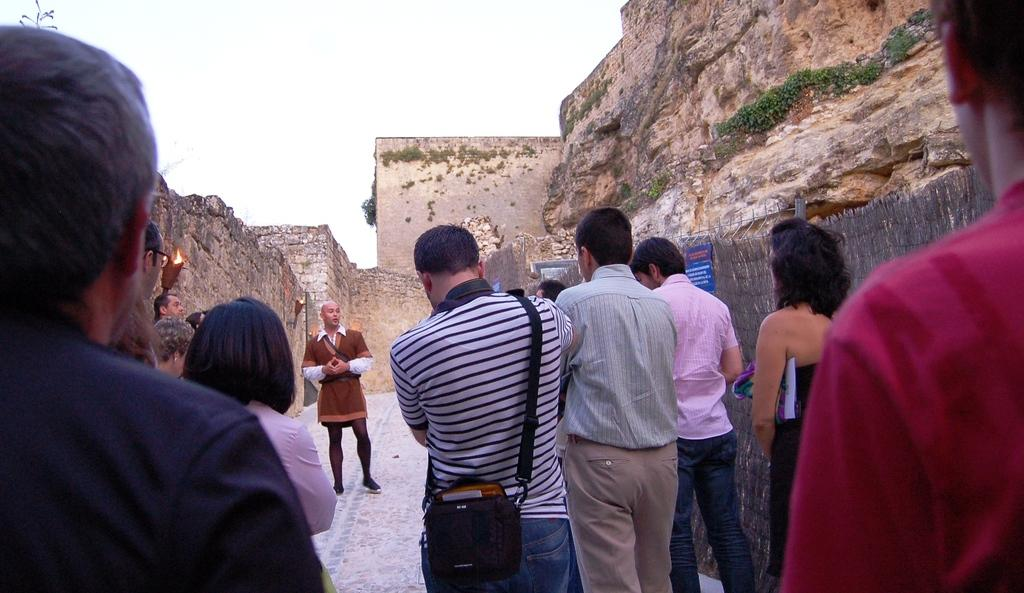What can be seen in the foreground of the image? There are people standing in the foreground of the image. Can you describe one of the people in the foreground? One man in the foreground is wearing a bag. What is visible in the background of the image? There is a wall, fencing, a cliff, and the sky visible in the background of the image. How many people can be seen in the image? There is one man standing in the background of the image, in addition to the people in the foreground. Where is the shelf located in the image? There is no shelf present in the image. What type of society is depicted in the image? The image does not depict a society; it shows people standing in the foreground and various elements in the background. 